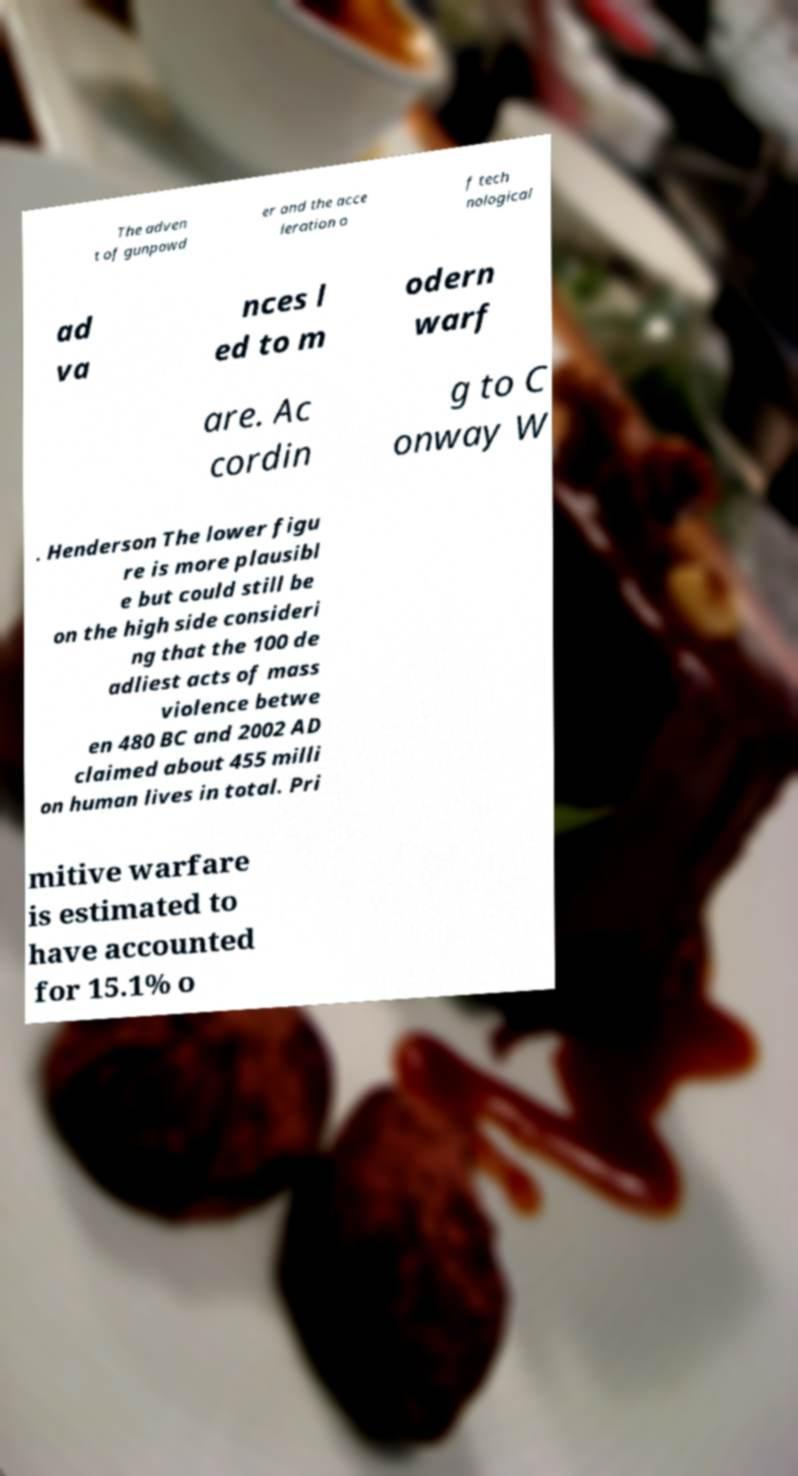Can you read and provide the text displayed in the image?This photo seems to have some interesting text. Can you extract and type it out for me? The adven t of gunpowd er and the acce leration o f tech nological ad va nces l ed to m odern warf are. Ac cordin g to C onway W . Henderson The lower figu re is more plausibl e but could still be on the high side consideri ng that the 100 de adliest acts of mass violence betwe en 480 BC and 2002 AD claimed about 455 milli on human lives in total. Pri mitive warfare is estimated to have accounted for 15.1% o 